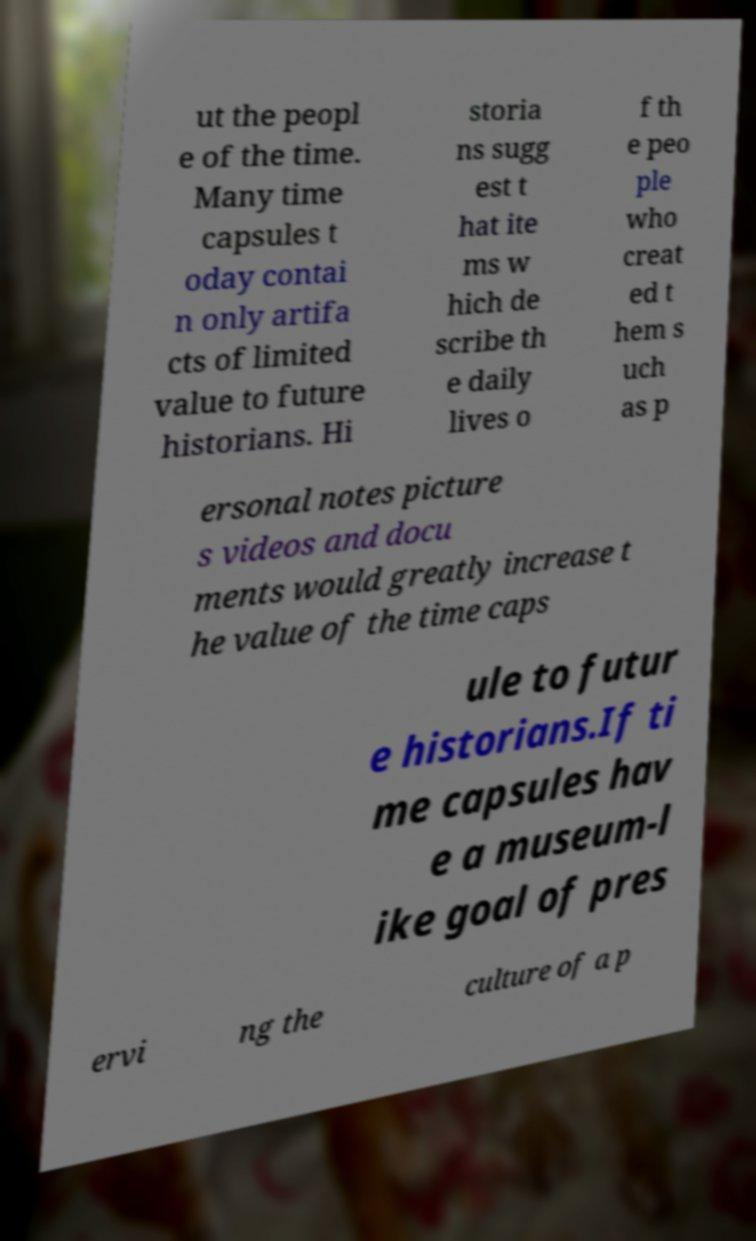Could you assist in decoding the text presented in this image and type it out clearly? ut the peopl e of the time. Many time capsules t oday contai n only artifa cts of limited value to future historians. Hi storia ns sugg est t hat ite ms w hich de scribe th e daily lives o f th e peo ple who creat ed t hem s uch as p ersonal notes picture s videos and docu ments would greatly increase t he value of the time caps ule to futur e historians.If ti me capsules hav e a museum-l ike goal of pres ervi ng the culture of a p 